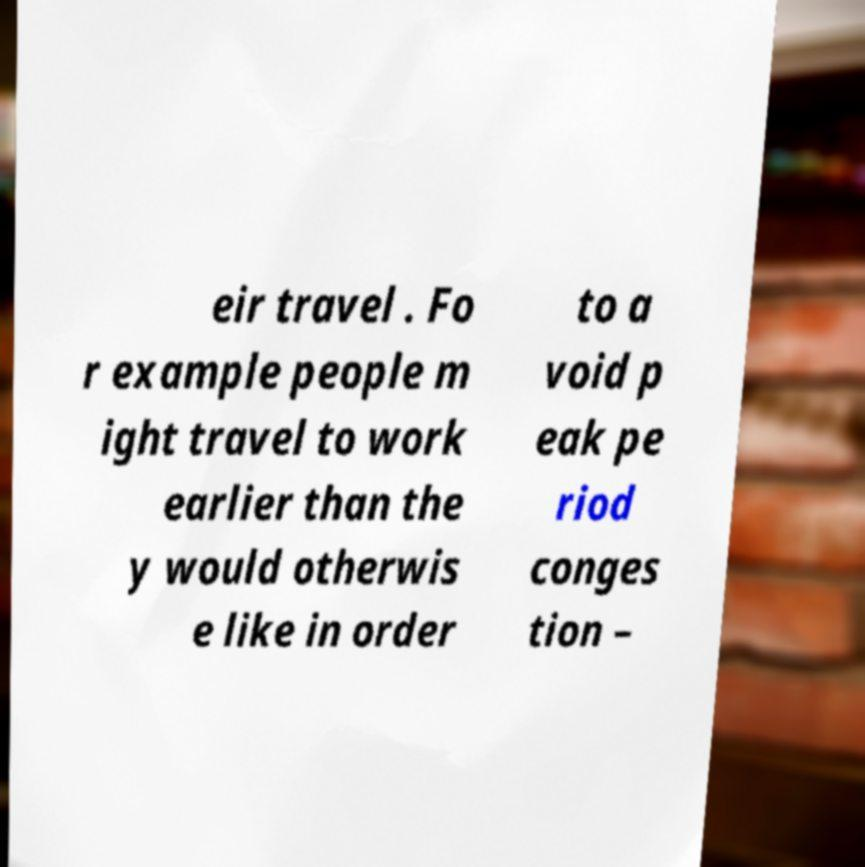I need the written content from this picture converted into text. Can you do that? eir travel . Fo r example people m ight travel to work earlier than the y would otherwis e like in order to a void p eak pe riod conges tion – 